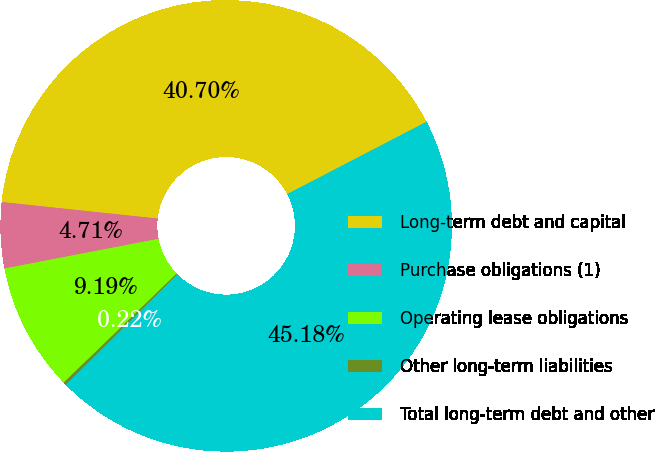Convert chart to OTSL. <chart><loc_0><loc_0><loc_500><loc_500><pie_chart><fcel>Long-term debt and capital<fcel>Purchase obligations (1)<fcel>Operating lease obligations<fcel>Other long-term liabilities<fcel>Total long-term debt and other<nl><fcel>40.7%<fcel>4.71%<fcel>9.19%<fcel>0.22%<fcel>45.18%<nl></chart> 